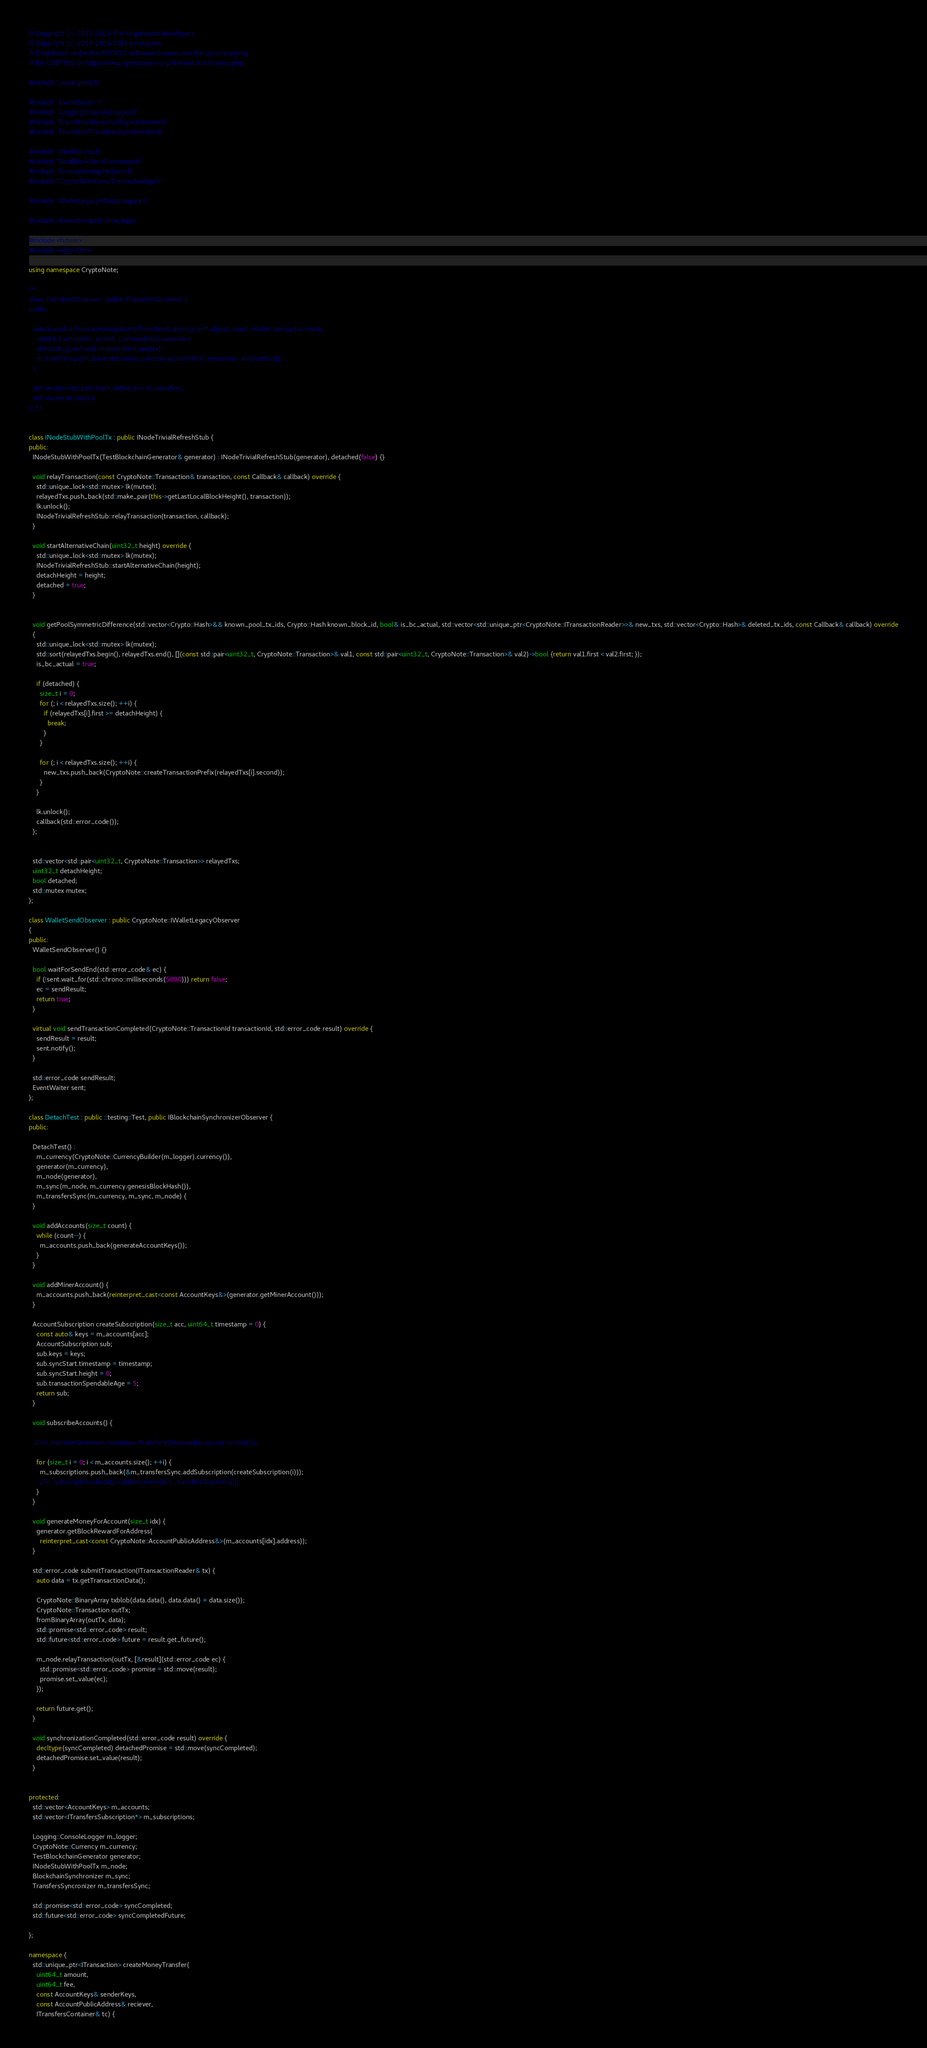Convert code to text. <code><loc_0><loc_0><loc_500><loc_500><_C++_>// Copyright (c) 2011-2016 The Cryptonote developers
// Copyright (c) 2014-2016 SDN developers
// Distributed under the MIT/X11 software license, see the accompanying
// file COPYING or http://www.opensource.org/licenses/mit-license.php.

#include "gtest/gtest.h"

#include "EventWaiter.h"
#include "Logging/ConsoleLogger.h"
#include "Transfers/BlockchainSynchronizer.h"
#include "Transfers/TransfersSynchronizer.h"

#include "INodeStubs.h"
#include "TestBlockchainGenerator.h"
#include "TransactionApiHelpers.h"
#include "CryptoNoteCore/TransactionApi.h"

#include "WalletLegacy/WalletLegacy.h"

#include <boost/scoped_array.hpp>

#include <future>
#include <algorithm>

using namespace CryptoNote;

/*
class TransfersObserver : public ITransfersObserver {
public:

  virtual void onTransactionUpdated(ITransfersSubscription* object, const Hash& transactionHash,
    uint64_t amountIn, uint64_t amountOut) override {
    std::lock_guard<std::mutex> lk(m_mutex);
    m_transfers.push_back(std::make_pair(transactionHash, amountIn - amountOut));
  }

  std::vector<std::pair<Hash, int64_t>> m_transfers;
  std::mutex m_mutex;
}; */


class INodeStubWithPoolTx : public INodeTrivialRefreshStub {
public:
  INodeStubWithPoolTx(TestBlockchainGenerator& generator) : INodeTrivialRefreshStub(generator), detached(false) {}

  void relayTransaction(const CryptoNote::Transaction& transaction, const Callback& callback) override {
    std::unique_lock<std::mutex> lk(mutex);
    relayedTxs.push_back(std::make_pair(this->getLastLocalBlockHeight(), transaction));
    lk.unlock();
    INodeTrivialRefreshStub::relayTransaction(transaction, callback);
  }

  void startAlternativeChain(uint32_t height) override {
    std::unique_lock<std::mutex> lk(mutex);
    INodeTrivialRefreshStub::startAlternativeChain(height);
    detachHeight = height;
    detached = true;
  }


  void getPoolSymmetricDifference(std::vector<Crypto::Hash>&& known_pool_tx_ids, Crypto::Hash known_block_id, bool& is_bc_actual, std::vector<std::unique_ptr<CryptoNote::ITransactionReader>>& new_txs, std::vector<Crypto::Hash>& deleted_tx_ids, const Callback& callback) override
  {
    std::unique_lock<std::mutex> lk(mutex);
    std::sort(relayedTxs.begin(), relayedTxs.end(), [](const std::pair<uint32_t, CryptoNote::Transaction>& val1, const std::pair<uint32_t, CryptoNote::Transaction>& val2)->bool {return val1.first < val2.first; });
    is_bc_actual = true;
    
    if (detached) {
      size_t i = 0;
      for (; i < relayedTxs.size(); ++i) {
        if (relayedTxs[i].first >= detachHeight) {
          break;
        }
      }

      for (; i < relayedTxs.size(); ++i) {
        new_txs.push_back(CryptoNote::createTransactionPrefix(relayedTxs[i].second));
      }
    }

    lk.unlock();
    callback(std::error_code()); 
  };

  
  std::vector<std::pair<uint32_t, CryptoNote::Transaction>> relayedTxs;
  uint32_t detachHeight;
  bool detached;
  std::mutex mutex;
};

class WalletSendObserver : public CryptoNote::IWalletLegacyObserver
{
public:
  WalletSendObserver() {}

  bool waitForSendEnd(std::error_code& ec) {
    if (!sent.wait_for(std::chrono::milliseconds(5000))) return false;
    ec = sendResult;
    return true;
  }

  virtual void sendTransactionCompleted(CryptoNote::TransactionId transactionId, std::error_code result) override {
    sendResult = result;
    sent.notify();
  }

  std::error_code sendResult;
  EventWaiter sent;
};

class DetachTest : public ::testing::Test, public IBlockchainSynchronizerObserver {
public:

  DetachTest() :
    m_currency(CryptoNote::CurrencyBuilder(m_logger).currency()),
    generator(m_currency),
    m_node(generator),
    m_sync(m_node, m_currency.genesisBlockHash()),
    m_transfersSync(m_currency, m_sync, m_node) {
  }

  void addAccounts(size_t count) {
    while (count--) {
      m_accounts.push_back(generateAccountKeys());
    }
  }

  void addMinerAccount() {
    m_accounts.push_back(reinterpret_cast<const AccountKeys&>(generator.getMinerAccount()));
  }

  AccountSubscription createSubscription(size_t acc, uint64_t timestamp = 0) {
    const auto& keys = m_accounts[acc];
    AccountSubscription sub;
    sub.keys = keys;
    sub.syncStart.timestamp = timestamp;
    sub.syncStart.height = 0;
    sub.transactionSpendableAge = 5;
    return sub;
  }

  void subscribeAccounts() {

   // m_transferObservers.reset(new TransfersObserver[m_accounts.size()]);

    for (size_t i = 0; i < m_accounts.size(); ++i) {
      m_subscriptions.push_back(&m_transfersSync.addSubscription(createSubscription(i)));
      //m_subscriptions.back()->addObserver(&m_transferObservers[i]);
    }
  }

  void generateMoneyForAccount(size_t idx) {
    generator.getBlockRewardForAddress(
      reinterpret_cast<const CryptoNote::AccountPublicAddress&>(m_accounts[idx].address));
  }

  std::error_code submitTransaction(ITransactionReader& tx) {
    auto data = tx.getTransactionData();

    CryptoNote::BinaryArray txblob(data.data(), data.data() + data.size());
    CryptoNote::Transaction outTx;
    fromBinaryArray(outTx, data);
    std::promise<std::error_code> result;
    std::future<std::error_code> future = result.get_future();

    m_node.relayTransaction(outTx, [&result](std::error_code ec) {
      std::promise<std::error_code> promise = std::move(result);
      promise.set_value(ec);
    });

    return future.get();
  }

  void synchronizationCompleted(std::error_code result) override {
    decltype(syncCompleted) detachedPromise = std::move(syncCompleted);
    detachedPromise.set_value(result);
  }


protected:
  std::vector<AccountKeys> m_accounts;
  std::vector<ITransfersSubscription*> m_subscriptions;

  Logging::ConsoleLogger m_logger;
  CryptoNote::Currency m_currency;
  TestBlockchainGenerator generator;
  INodeStubWithPoolTx m_node;
  BlockchainSynchronizer m_sync;
  TransfersSyncronizer m_transfersSync;

  std::promise<std::error_code> syncCompleted;
  std::future<std::error_code> syncCompletedFuture;

};

namespace {
  std::unique_ptr<ITransaction> createMoneyTransfer(
    uint64_t amount,
    uint64_t fee,
    const AccountKeys& senderKeys,
    const AccountPublicAddress& reciever,
    ITransfersContainer& tc) {
</code> 